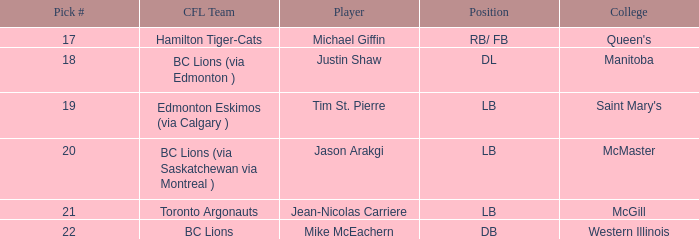What pick # did Western Illinois have? 22.0. 